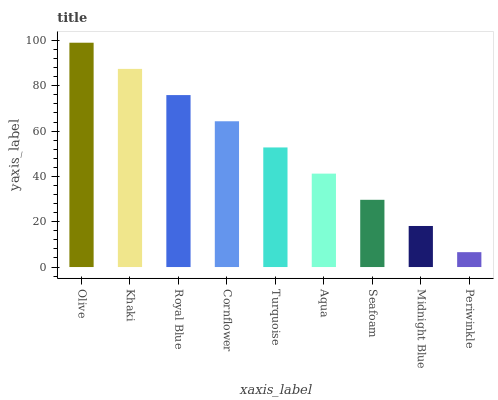Is Khaki the minimum?
Answer yes or no. No. Is Khaki the maximum?
Answer yes or no. No. Is Olive greater than Khaki?
Answer yes or no. Yes. Is Khaki less than Olive?
Answer yes or no. Yes. Is Khaki greater than Olive?
Answer yes or no. No. Is Olive less than Khaki?
Answer yes or no. No. Is Turquoise the high median?
Answer yes or no. Yes. Is Turquoise the low median?
Answer yes or no. Yes. Is Royal Blue the high median?
Answer yes or no. No. Is Royal Blue the low median?
Answer yes or no. No. 